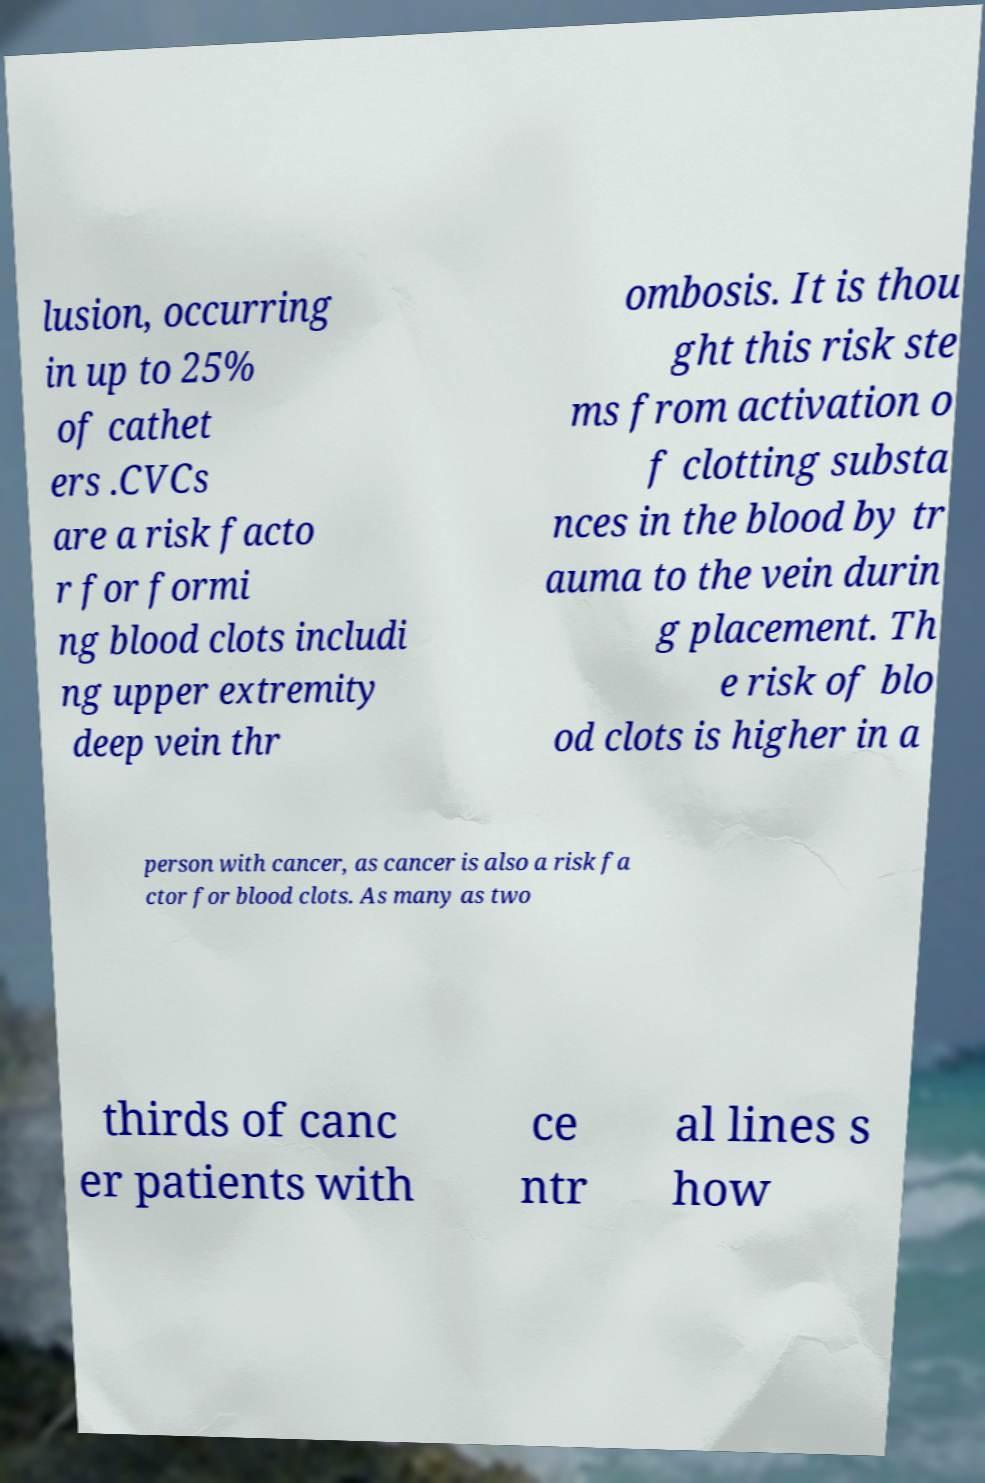Can you read and provide the text displayed in the image?This photo seems to have some interesting text. Can you extract and type it out for me? lusion, occurring in up to 25% of cathet ers .CVCs are a risk facto r for formi ng blood clots includi ng upper extremity deep vein thr ombosis. It is thou ght this risk ste ms from activation o f clotting substa nces in the blood by tr auma to the vein durin g placement. Th e risk of blo od clots is higher in a person with cancer, as cancer is also a risk fa ctor for blood clots. As many as two thirds of canc er patients with ce ntr al lines s how 